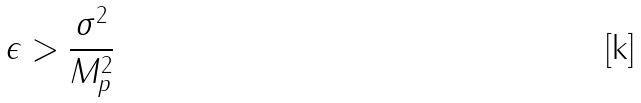Convert formula to latex. <formula><loc_0><loc_0><loc_500><loc_500>\epsilon > \frac { \sigma ^ { 2 } } { M _ { p } ^ { 2 } }</formula> 